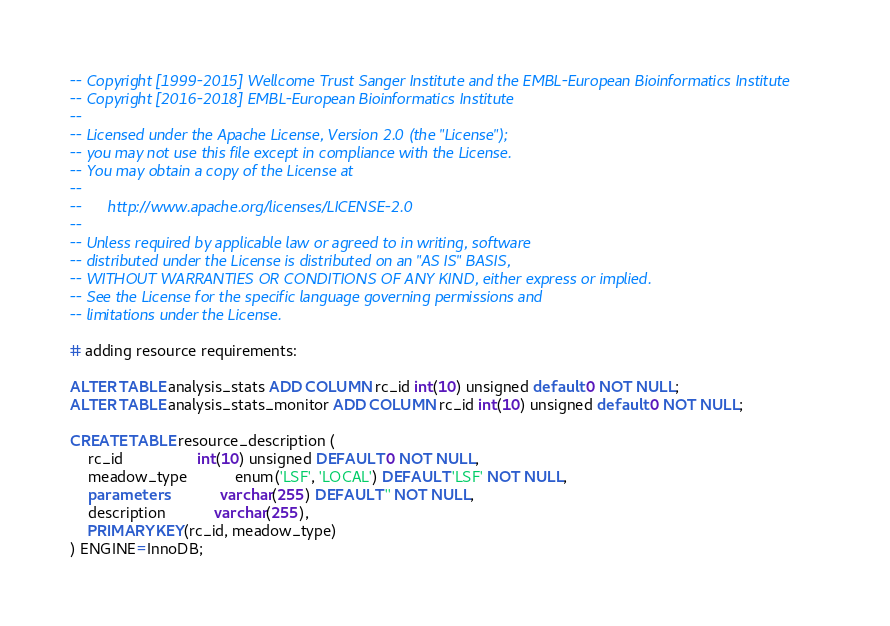Convert code to text. <code><loc_0><loc_0><loc_500><loc_500><_SQL_>-- Copyright [1999-2015] Wellcome Trust Sanger Institute and the EMBL-European Bioinformatics Institute
-- Copyright [2016-2018] EMBL-European Bioinformatics Institute
-- 
-- Licensed under the Apache License, Version 2.0 (the "License");
-- you may not use this file except in compliance with the License.
-- You may obtain a copy of the License at
-- 
--      http://www.apache.org/licenses/LICENSE-2.0
-- 
-- Unless required by applicable law or agreed to in writing, software
-- distributed under the License is distributed on an "AS IS" BASIS,
-- WITHOUT WARRANTIES OR CONDITIONS OF ANY KIND, either express or implied.
-- See the License for the specific language governing permissions and
-- limitations under the License.

# adding resource requirements:

ALTER TABLE analysis_stats ADD COLUMN rc_id int(10) unsigned default 0 NOT NULL;
ALTER TABLE analysis_stats_monitor ADD COLUMN rc_id int(10) unsigned default 0 NOT NULL;

CREATE TABLE resource_description (
    rc_id                 int(10) unsigned DEFAULT 0 NOT NULL,
    meadow_type           enum('LSF', 'LOCAL') DEFAULT 'LSF' NOT NULL,
    parameters            varchar(255) DEFAULT '' NOT NULL,
    description           varchar(255),
    PRIMARY KEY(rc_id, meadow_type)
) ENGINE=InnoDB;

</code> 